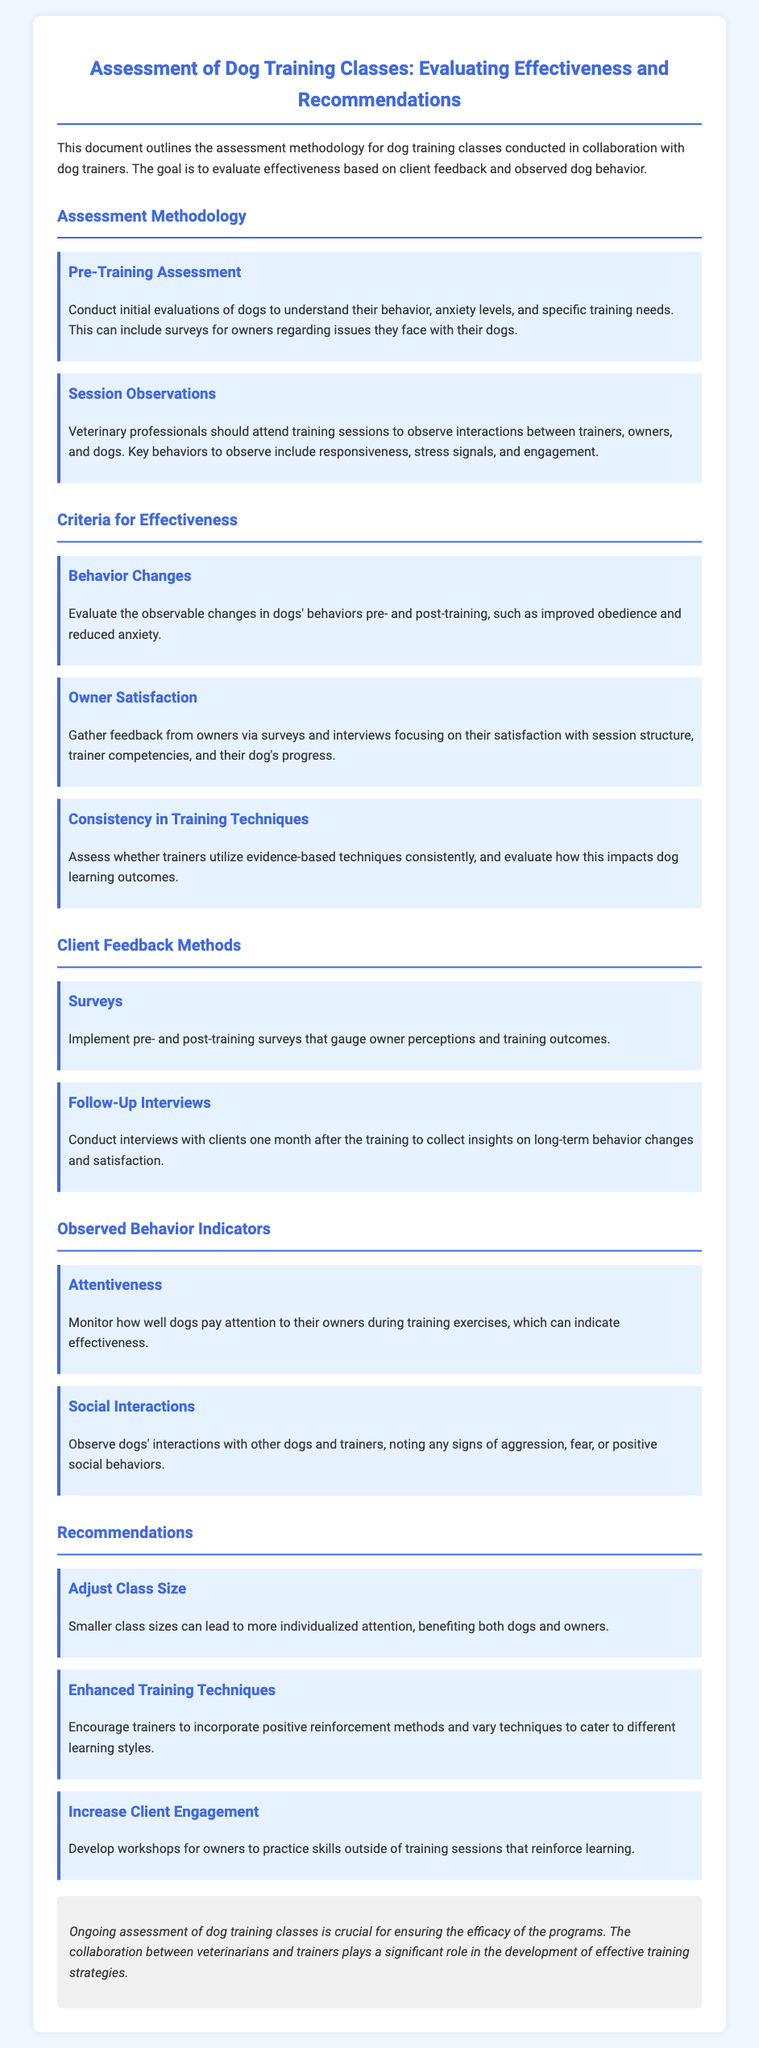What is the title of the document? The title appears at the top and describes the focus of the assessment.
Answer: Assessment of Dog Training Classes: Evaluating Effectiveness and Recommendations What is the goal of the document? The opening paragraph outlines the aim of evaluating dog training effectiveness based on specific factors.
Answer: Evaluate effectiveness What is the first step in the assessment methodology? The section on assessment methodology describes initial evaluations done before training begins.
Answer: Pre-Training Assessment How is owner satisfaction measured? The criteria for effectiveness includes a subsection dedicated to gathering feedback from owners about their experience.
Answer: Surveys and interviews What behavior is monitored during training sessions? The document lists specific behaviors that are observed to assess training effectiveness.
Answer: Attentiveness What recommendation is made regarding class size? The recommendations section suggests an approach to improve training effectiveness by managing class sizes.
Answer: Adjust Class Size What type of training methods are encouraged? The recommendations provide insight into the types of techniques that should be enhanced for better outcomes.
Answer: Positive reinforcement methods How long after training are follow-up interviews conducted? The section on client feedback methods specifies the timeline for follow-up interviews to assess long-term effects.
Answer: One month What is crucial for ensuring program efficacy? The conclusion emphasizes the importance of ongoing collaboration in the assessment of training classes.
Answer: Ongoing assessment 